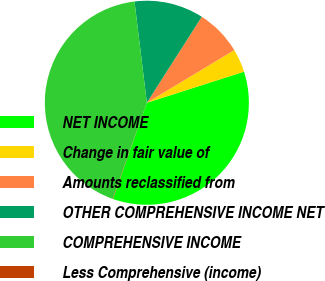Convert chart. <chart><loc_0><loc_0><loc_500><loc_500><pie_chart><fcel>NET INCOME<fcel>Change in fair value of<fcel>Amounts reclassified from<fcel>OTHER COMPREHENSIVE INCOME NET<fcel>COMPREHENSIVE INCOME<fcel>Less Comprehensive (income)<nl><fcel>35.33%<fcel>3.69%<fcel>7.33%<fcel>10.98%<fcel>42.62%<fcel>0.05%<nl></chart> 